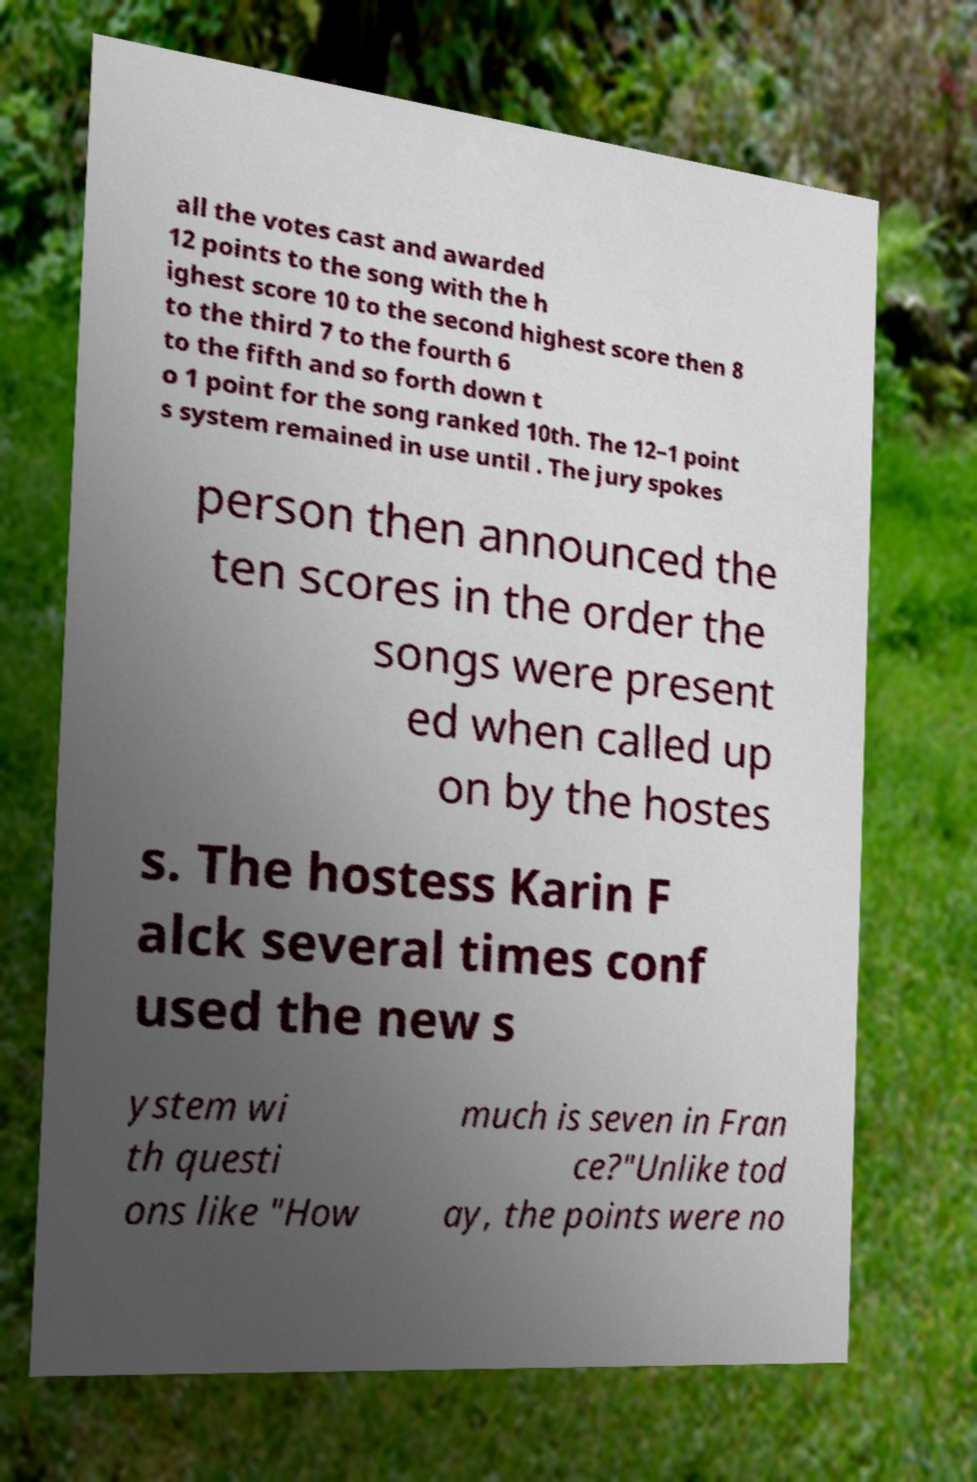There's text embedded in this image that I need extracted. Can you transcribe it verbatim? all the votes cast and awarded 12 points to the song with the h ighest score 10 to the second highest score then 8 to the third 7 to the fourth 6 to the fifth and so forth down t o 1 point for the song ranked 10th. The 12–1 point s system remained in use until . The jury spokes person then announced the ten scores in the order the songs were present ed when called up on by the hostes s. The hostess Karin F alck several times conf used the new s ystem wi th questi ons like "How much is seven in Fran ce?"Unlike tod ay, the points were no 